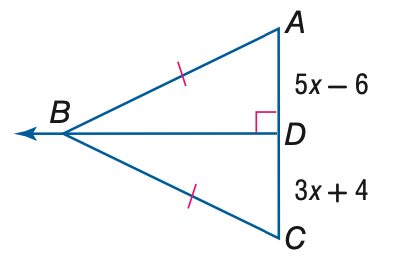Question: Find the measure of A C.
Choices:
A. 19
B. 30
C. 38
D. 76
Answer with the letter. Answer: C 